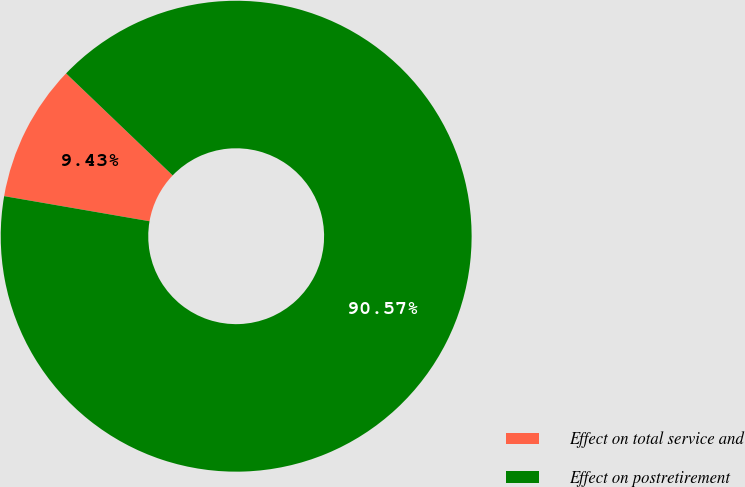Convert chart to OTSL. <chart><loc_0><loc_0><loc_500><loc_500><pie_chart><fcel>Effect on total service and<fcel>Effect on postretirement<nl><fcel>9.43%<fcel>90.57%<nl></chart> 